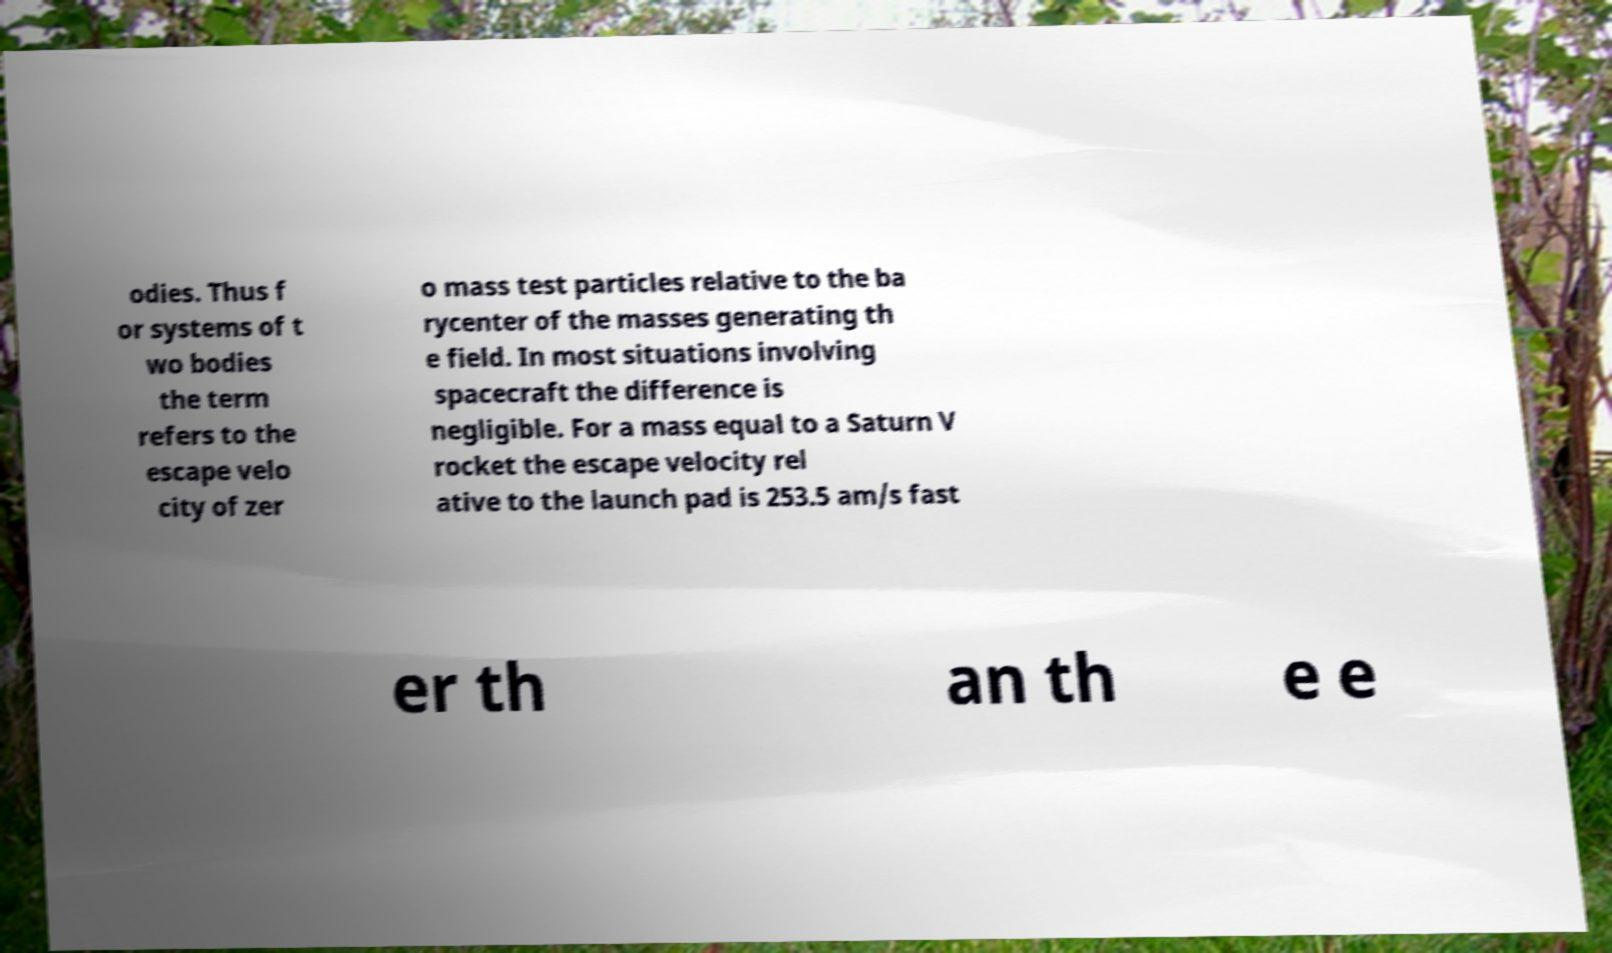There's text embedded in this image that I need extracted. Can you transcribe it verbatim? odies. Thus f or systems of t wo bodies the term refers to the escape velo city of zer o mass test particles relative to the ba rycenter of the masses generating th e field. In most situations involving spacecraft the difference is negligible. For a mass equal to a Saturn V rocket the escape velocity rel ative to the launch pad is 253.5 am/s fast er th an th e e 